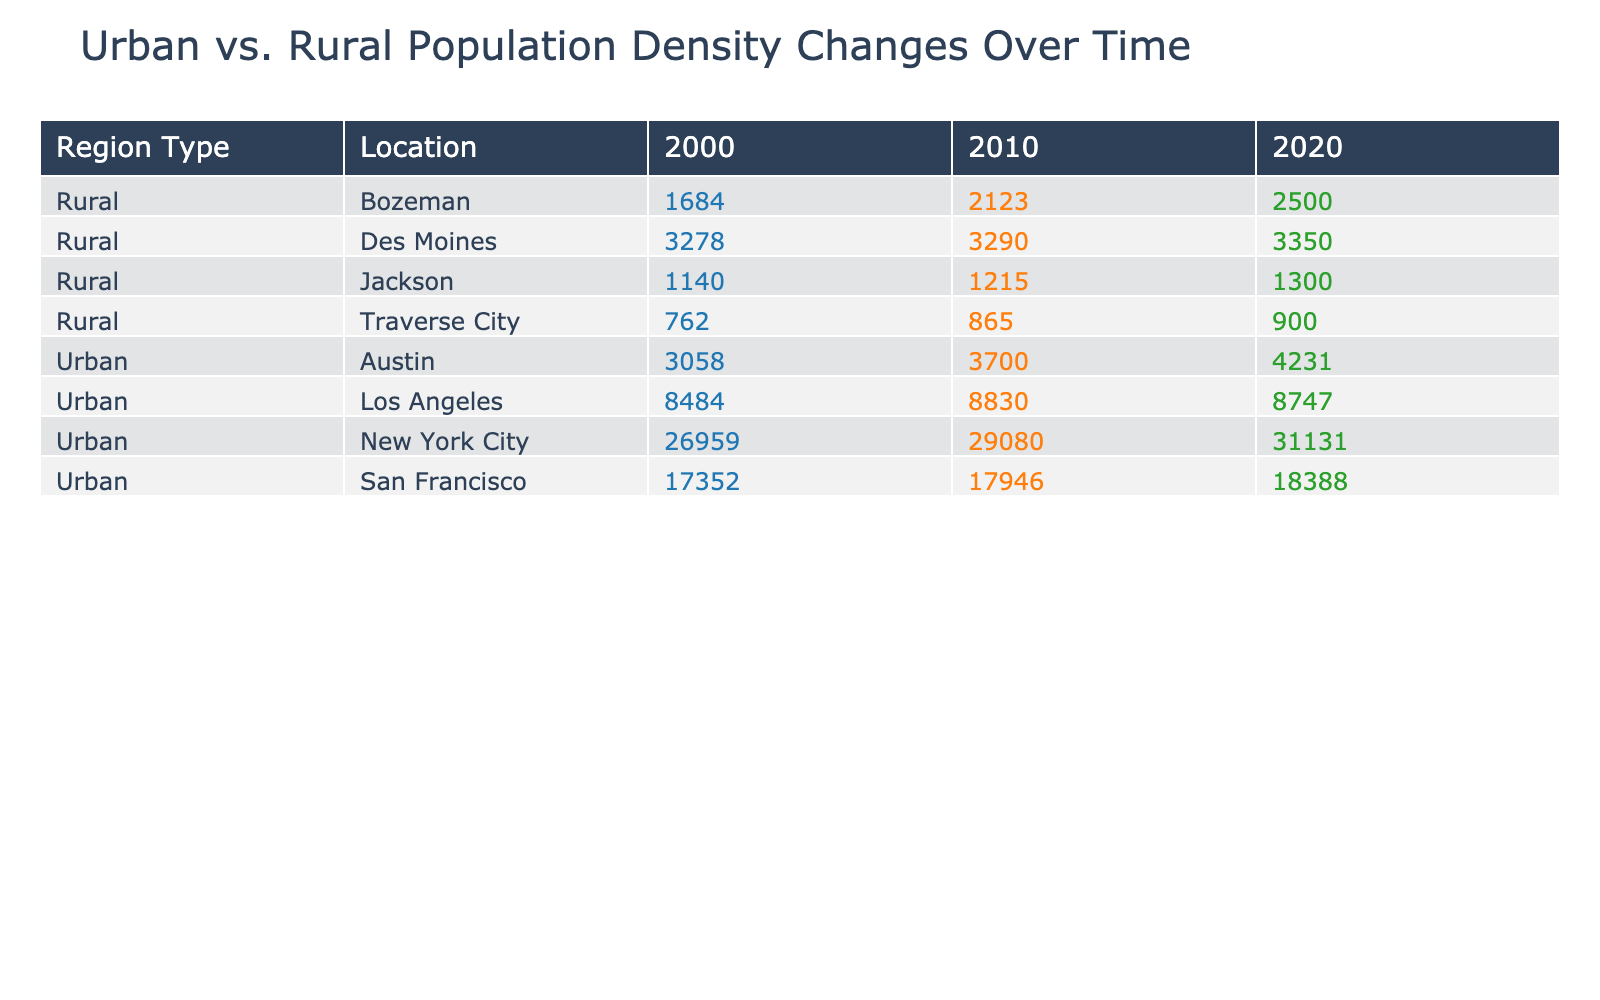What was the population density of San Francisco in 2020? The table shows the population density for each location and year. For San Francisco in 2020, the value is listed as 18388 people per square mile.
Answer: 18388 Which urban area had the highest population density in 2010? By comparing the population densities of the urban areas in 2010, New York City has a density of 29080, Los Angeles has 8830, Austin has 3700, and San Francisco has 17946. New York City has the highest value.
Answer: New York City What was the increase in population density for Austin from 2000 to 2020? For Austin, the population density in 2000 was 3058 and in 2020 it was 4231. The increase is calculated by subtracting: 4231 - 3058 = 1173.
Answer: 1173 Is the population density of Bozeman higher in 2020 compared to 2010? In 2010, Bozeman had a population density of 2123 and in 2020 it increased to 2500. Thus, the answer is yes, it is higher.
Answer: Yes What was the average population density of rural locations in 2000? The rural locations are Des Moines (3278), Bozeman (1684), Traverse City (762), and Jackson (1140). Adding these gives 3278 + 1684 + 762 + 1140 = 6864. Dividing by the number of locations (4), the average is 6864 / 4 = 1716.
Answer: 1716 How much did the population density of New York City grow from 2000 to 2020? The population density of New York City in 2000 was 26959 and in 2020 it grew to 31131. The growth is determined by subtracting the earlier value from the later value: 31131 - 26959 = 4182.
Answer: 4182 Was the population density of Jackson consistently lower than 2000 in subsequent years? In 2000, Jackson had a density of 1140. In 2010 it was 1215, and in 2020 it rose to 1300. Since both values from subsequent years are higher than 2000, the answer is no.
Answer: No Which rural area saw the greatest population density increase from 2010 to 2020? The rural areas in 2010 were: Des Moines (3290), Bozeman (2123), Traverse City (865), and Jackson (1215). Their population densities in 2020 were Des Moines (3350), Bozeman (2500), Traverse City (900), and Jackson (1300). The increases are as follows: Des Moines: 3350 - 3290 = 60, Bozeman: 2500 - 2123 = 377, Traverse City: 900 - 865 = 35, Jackson: 1300 - 1215 = 85. The greatest increase is for Bozeman.
Answer: Bozeman 